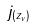<formula> <loc_0><loc_0><loc_500><loc_500>j _ { ( z _ { v } ) }</formula> 